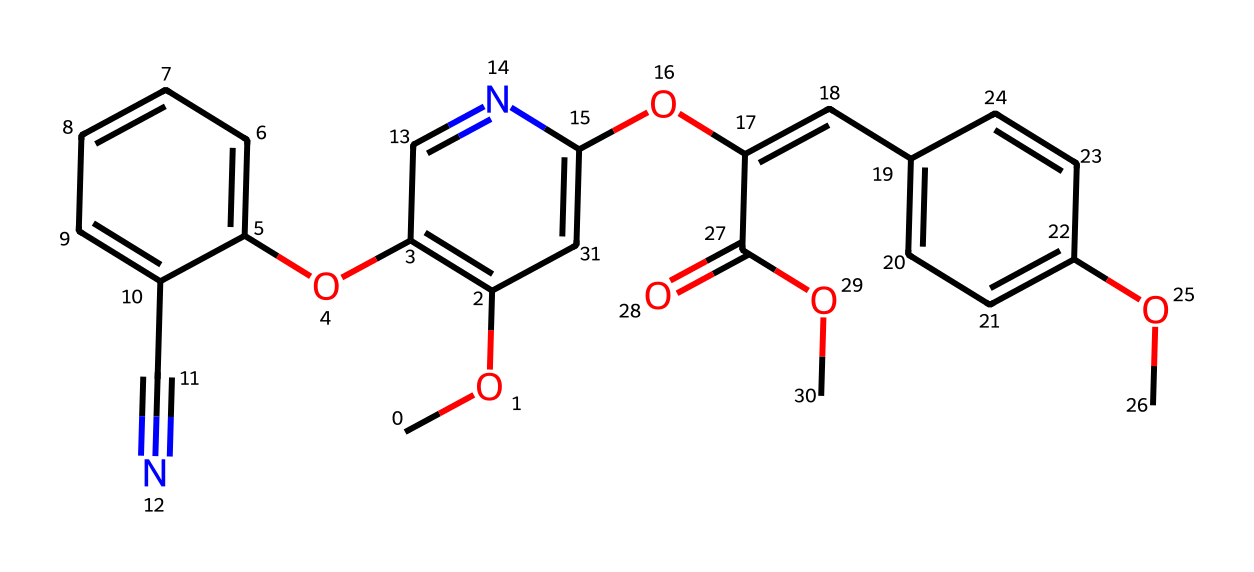What is the main functional group present in azoxystrobin? The structure contains an ester functional group indicated by the carbonyl (C=O) adjacent to an oxygen atom (OC), which is typical in fungicides providing necessary reactivity.
Answer: ester How many rings are present in the azoxystrobin structure? Upon examining the structure, there are two distinct ring systems visible in the chemical representation (an aromatic and a cyclic structure), indicating a total of two rings.
Answer: two What type of chemical bonds are predominantly found in azoxystrobin? The chemical features multiple covalent bonds, primarily characterized by single and double bonds among the carbon and nitrogen atoms throughout the structure.
Answer: covalent What is the molecular formula for azoxystrobin? By analyzing the chemical structure and counting the atoms, the molecular formula can be derived as C19H22N4O5.
Answer: C19H22N4O5 How many nitrogen atoms are present in azoxystrobin? The structure reveals four nitrogen atoms distributed throughout the molecule, confirming its role in the chemical's biological activity.
Answer: four What type of pesticide is azoxystrobin classified as? Given its chemical structure and function in agriculture, azoxystrobin is specifically classified as a fungicide, targeting fungal pathogens in crops.
Answer: fungicide 